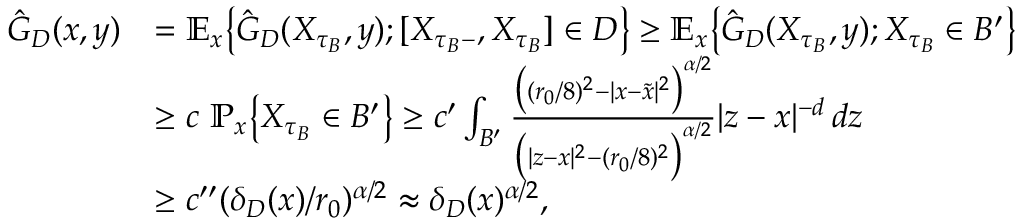Convert formula to latex. <formula><loc_0><loc_0><loc_500><loc_500>\begin{array} { r l } { \hat { G } _ { D } ( x , y ) } & { = { \mathbb { E } } _ { x } \left \{ \hat { G } _ { D } ( X _ { \tau _ { B } } , y ) ; [ X _ { \tau _ { B } - } , X _ { \tau _ { B } } ] \in D \right \} \geq { \mathbb { E } } _ { x } \left \{ \hat { G } _ { D } ( X _ { \tau _ { B } } , y ) ; X _ { \tau _ { B } } \in B ^ { \prime } \right \} } \\ & { \geq c { \mathbb { P } } _ { x } \left \{ X _ { \tau _ { B } } \in B ^ { \prime } \right \} \geq c ^ { \prime } \int _ { B ^ { \prime } } \frac { \left ( ( r _ { 0 } / 8 ) ^ { 2 } - | x - \tilde { x } | ^ { 2 } \right ) ^ { \alpha / 2 } } { \left ( | z - x | ^ { 2 } - ( r _ { 0 } / 8 ) ^ { 2 } \right ) ^ { \alpha / 2 } } | z - x | ^ { - d } \, d z } \\ & { \geq c ^ { \prime \prime } ( \delta _ { D } ( x ) / r _ { 0 } ) ^ { \alpha / 2 } \approx \delta _ { D } ( x ) ^ { \alpha / 2 } , } \end{array}</formula> 